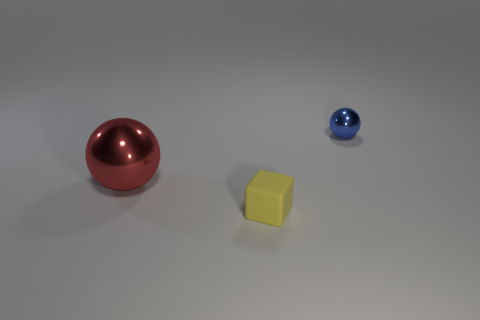Add 3 big red metal spheres. How many objects exist? 6 Subtract all blocks. How many objects are left? 2 Subtract all rubber blocks. Subtract all metal things. How many objects are left? 0 Add 3 spheres. How many spheres are left? 5 Add 2 large brown metallic cubes. How many large brown metallic cubes exist? 2 Subtract 0 yellow spheres. How many objects are left? 3 